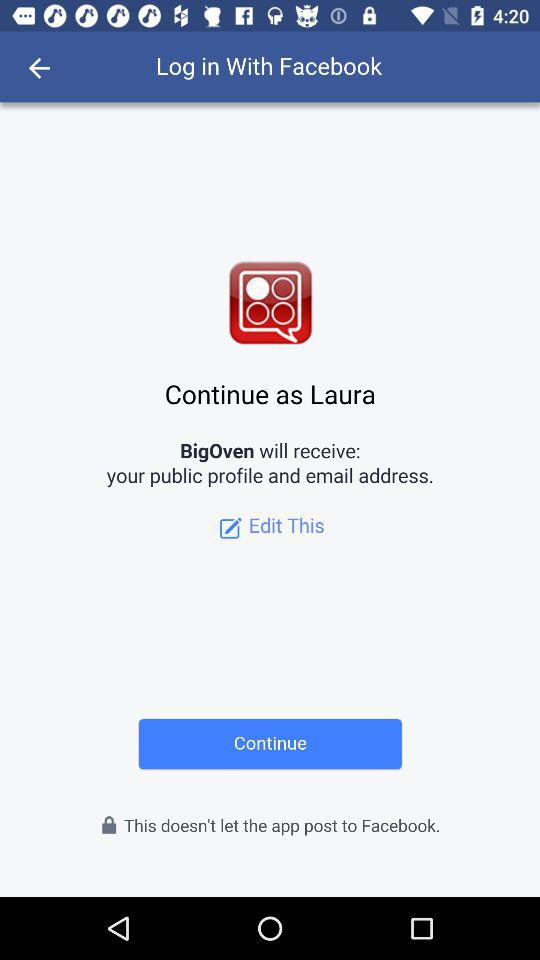What is the user name? The user name is Laura. 